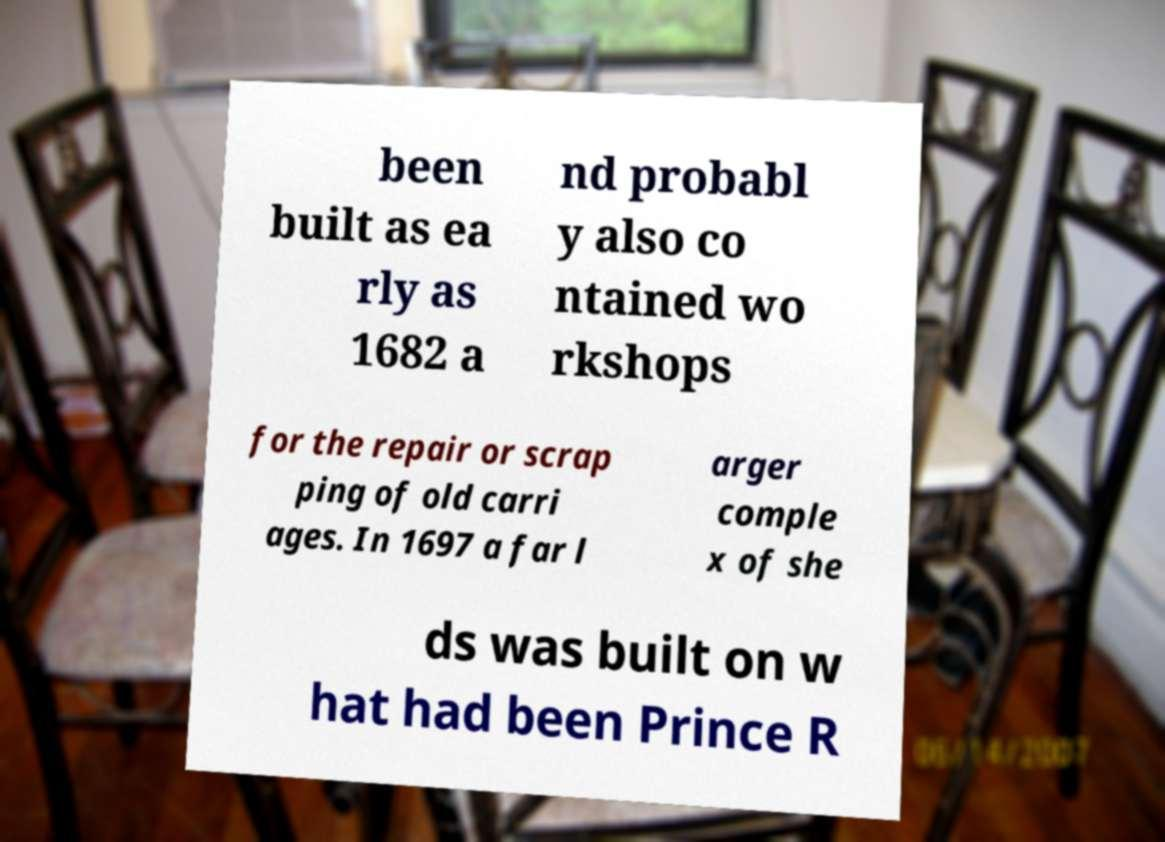Could you extract and type out the text from this image? been built as ea rly as 1682 a nd probabl y also co ntained wo rkshops for the repair or scrap ping of old carri ages. In 1697 a far l arger comple x of she ds was built on w hat had been Prince R 